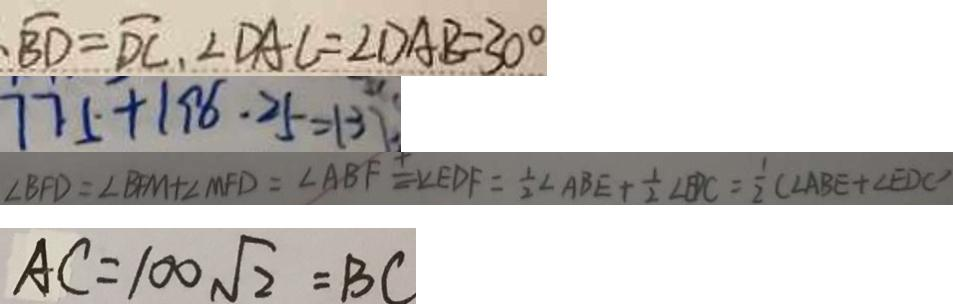Convert formula to latex. <formula><loc_0><loc_0><loc_500><loc_500>\overline { B D } = \widehat { D C } , \angle D A C = \angle D A B = 3 0 ^ { \circ } 
 7 7 5 + 1 9 6 . 2 5 = 1 3 7 
 \angle B F D = \angle B F M + \angle M F D = \angle A B F = \angle E D F = \frac { 1 } { 2 } \angle A B E + \frac { 1 } { 2 } B P C = \frac { 1 } { 2 } ( \angle A B E + \angle E D C 
 A C = 1 0 0 \sqrt { 2 } = B C</formula> 